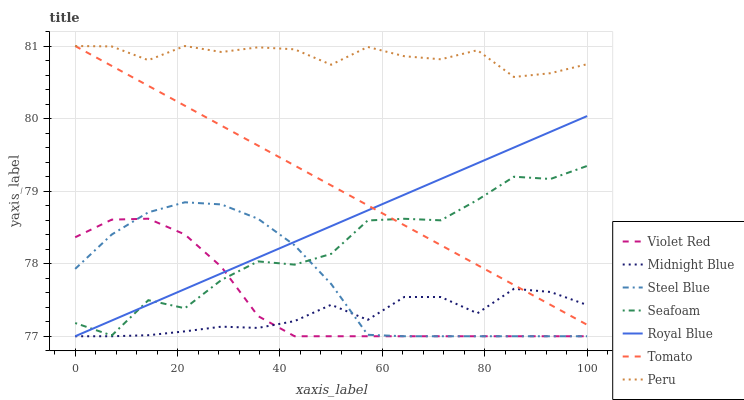Does Midnight Blue have the minimum area under the curve?
Answer yes or no. Yes. Does Peru have the maximum area under the curve?
Answer yes or no. Yes. Does Violet Red have the minimum area under the curve?
Answer yes or no. No. Does Violet Red have the maximum area under the curve?
Answer yes or no. No. Is Royal Blue the smoothest?
Answer yes or no. Yes. Is Seafoam the roughest?
Answer yes or no. Yes. Is Violet Red the smoothest?
Answer yes or no. No. Is Violet Red the roughest?
Answer yes or no. No. Does Violet Red have the lowest value?
Answer yes or no. Yes. Does Seafoam have the lowest value?
Answer yes or no. No. Does Peru have the highest value?
Answer yes or no. Yes. Does Violet Red have the highest value?
Answer yes or no. No. Is Royal Blue less than Peru?
Answer yes or no. Yes. Is Peru greater than Seafoam?
Answer yes or no. Yes. Does Midnight Blue intersect Royal Blue?
Answer yes or no. Yes. Is Midnight Blue less than Royal Blue?
Answer yes or no. No. Is Midnight Blue greater than Royal Blue?
Answer yes or no. No. Does Royal Blue intersect Peru?
Answer yes or no. No. 